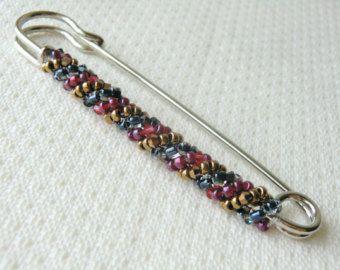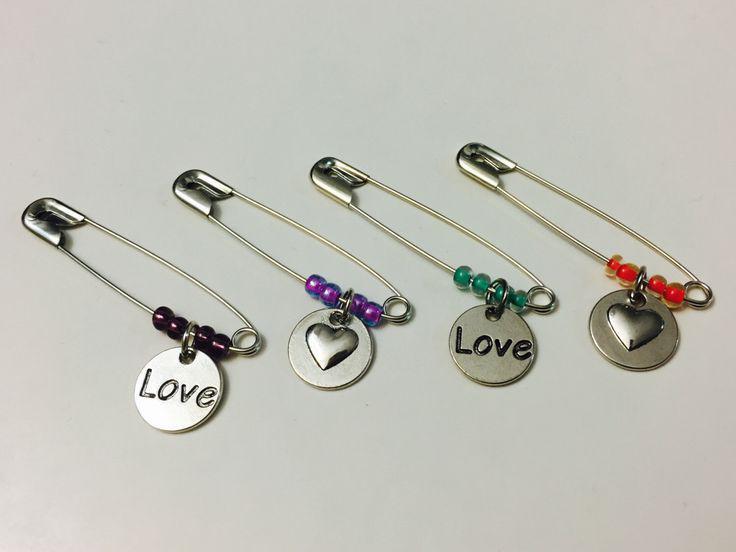The first image is the image on the left, the second image is the image on the right. Considering the images on both sides, is "Safety pins have be beaded to become fashion accessories. ." valid? Answer yes or no. Yes. The first image is the image on the left, the second image is the image on the right. Examine the images to the left and right. Is the description "The left image contains exactly two unadorned, separate safety pins, and the right image contains exactly four safety pins." accurate? Answer yes or no. No. 